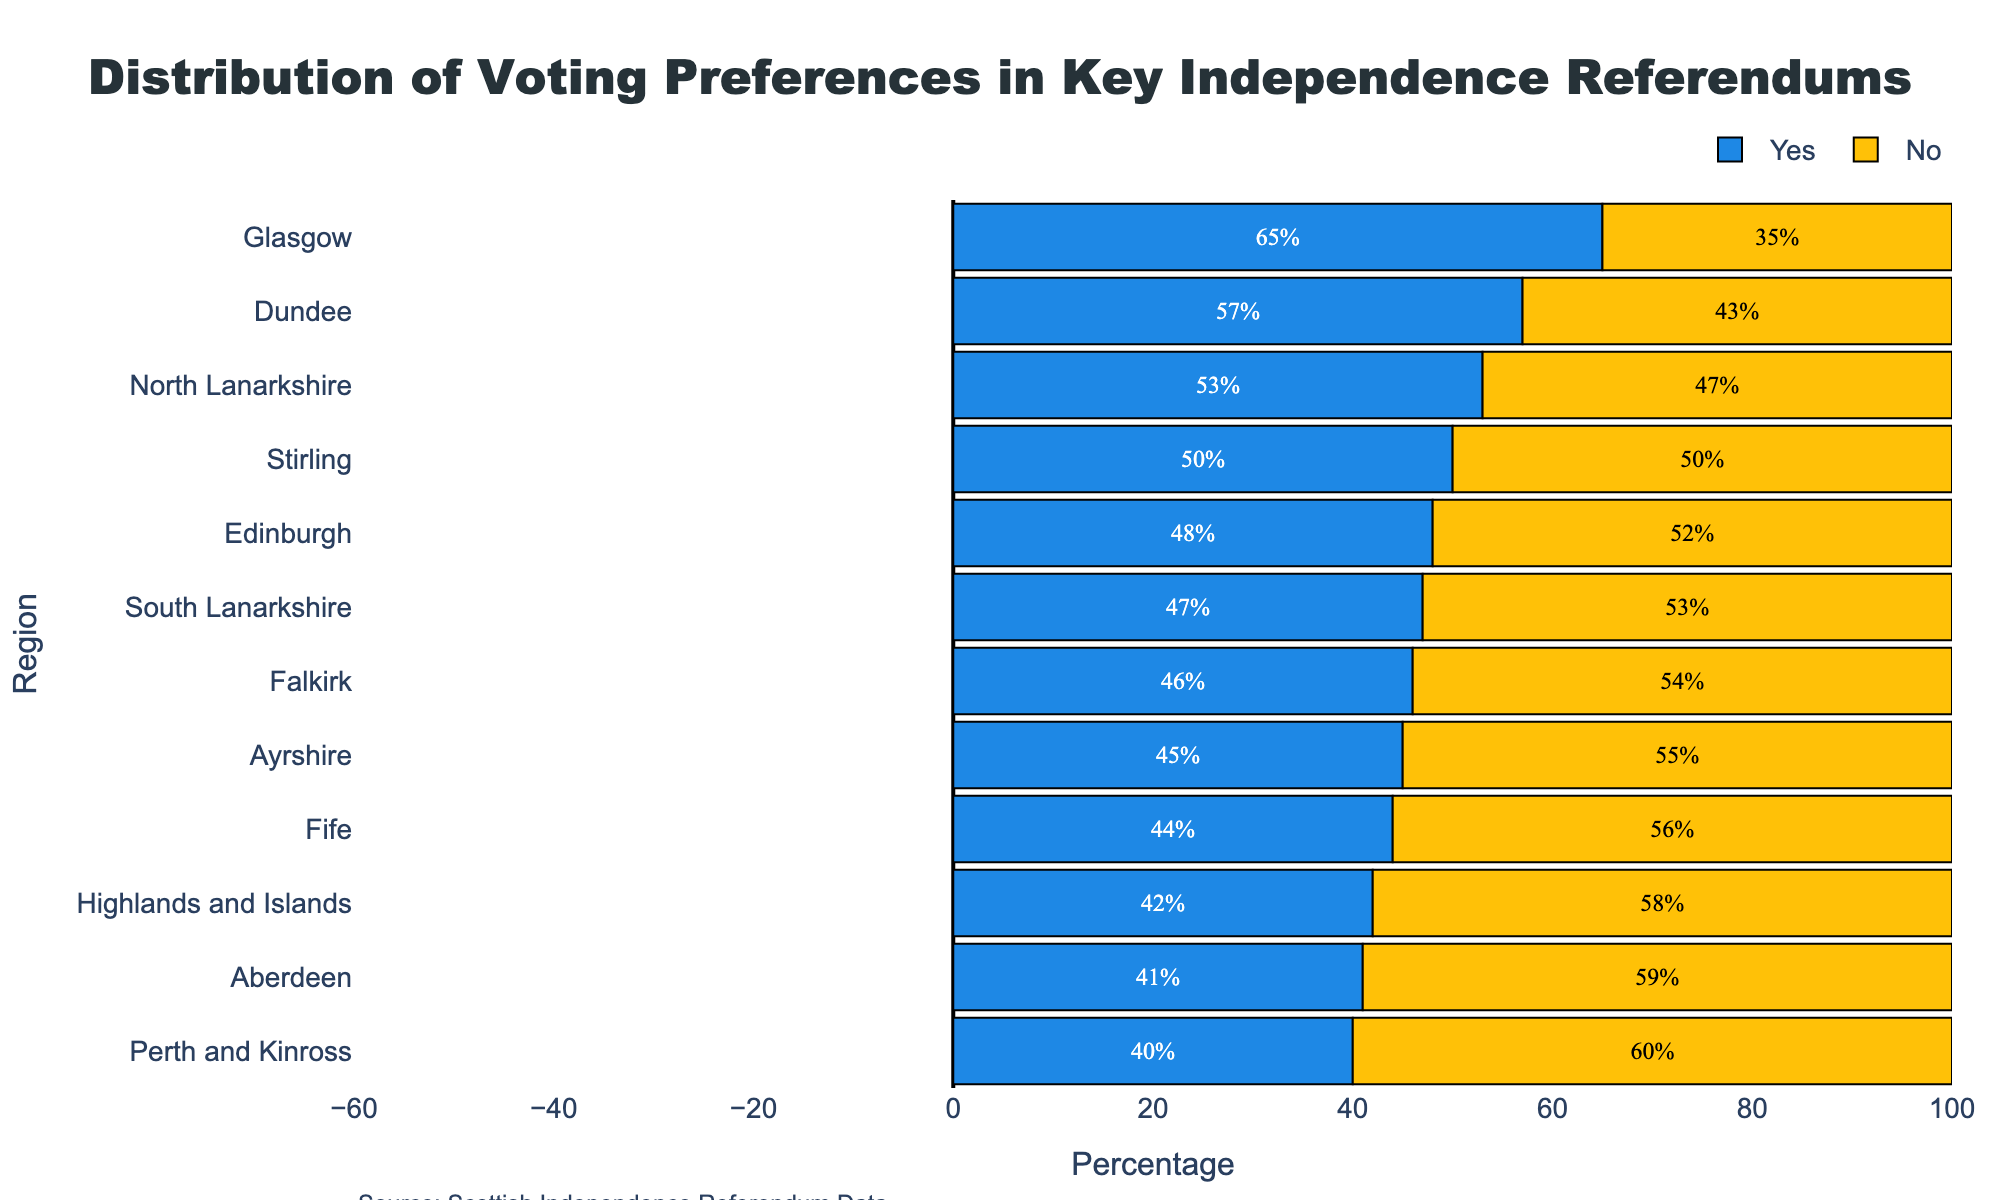Which region has the highest percentage of 'Yes' votes? The bars representing 'Yes' votes are sorted in descending order. The topmost bar belongs to Glasgow with a 'Yes' percentage of 65%.
Answer: Glasgow Which region has the lowest percentage of 'Yes' votes? The bars representing 'Yes' votes are sorted top to bottom. The bottom-most bar belongs to Perth and Kinross with a 'Yes' percentage of 40%.
Answer: Perth and Kinross What is the difference between 'Yes' votes in Glasgow and Perth and Kinross? Look at the 'Yes' percentages: Glasgow has 65%, and Perth and Kinross have 40%. The difference is 65% - 40% = 25%.
Answer: 25% Which regions have a 'Yes' percentage greater than 50%? Identify the regions where the 'Yes' bar extends past 50%. These regions are Glasgow (65%), Dundee (57%), and North Lanarkshire (53%).
Answer: Glasgow, Dundee, North Lanarkshire Are there any regions with an equal percentage of 'Yes' and 'No' votes? Look for a region where the 'Yes' and 'No' bars are of equal length. Stirling has 50% for both 'Yes' and 'No' votes.
Answer: Stirling What's the sum of the 'Yes' percentages for Edinburgh and Dundee? Add the 'Yes' percentages for Edinburgh (48%) and Dundee (57%). The sum is 48% + 57% = 105%.
Answer: 105% Which region has the highest percentage of 'No' votes? The highest 'No' percentage corresponds to the longest 'No' bar, which is 60% in Perth and Kinross.
Answer: Perth and Kinross How many regions have a 'No' percentage higher than 55%? Count the regions where 'No' is greater than 55%. These regions are Aberdeen (59%), Highlands and Islands (58%), and Perth and Kinross (60%). There are 3 regions.
Answer: 3 What is the average percentage of 'Yes' votes across all regions? Add all the 'Yes' percentages: (65 + 48 + 41 + 57 + 42 + 46 + 44 + 40 + 47 + 53 + 45 + 50) = 518. Divide by the number of regions (12). The average is 518/12 ≈ 43.17%.
Answer: 43.17% Compare the 'Yes' and 'No' totals for North Lanarkshire. Which one is higher and by how much? North Lanarkshire has 53% 'Yes' and 47% 'No'. The difference is 53% - 47% = 6%. 'Yes' is higher by 6%.
Answer: 'Yes' by 6% 